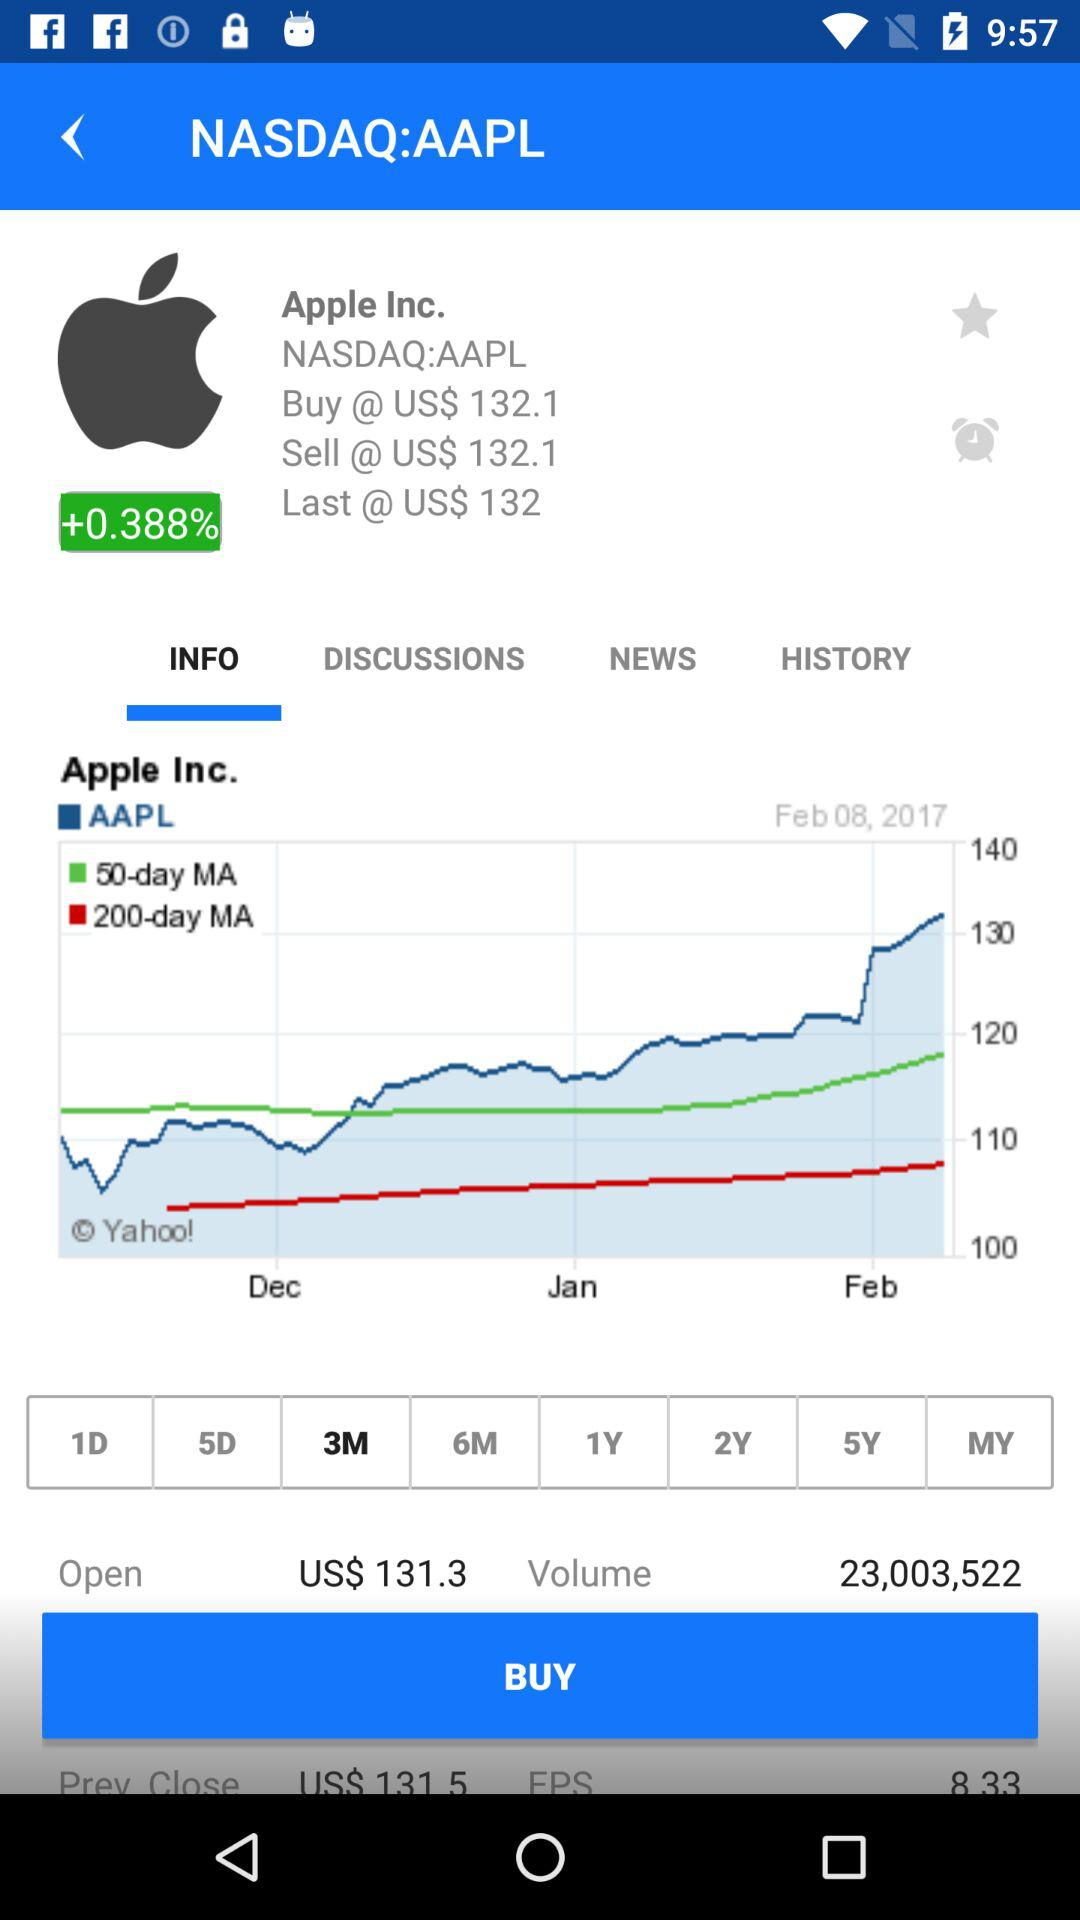How much percent is Apple Inc. up by? Apple Inc. is up by 0.388 percent. 